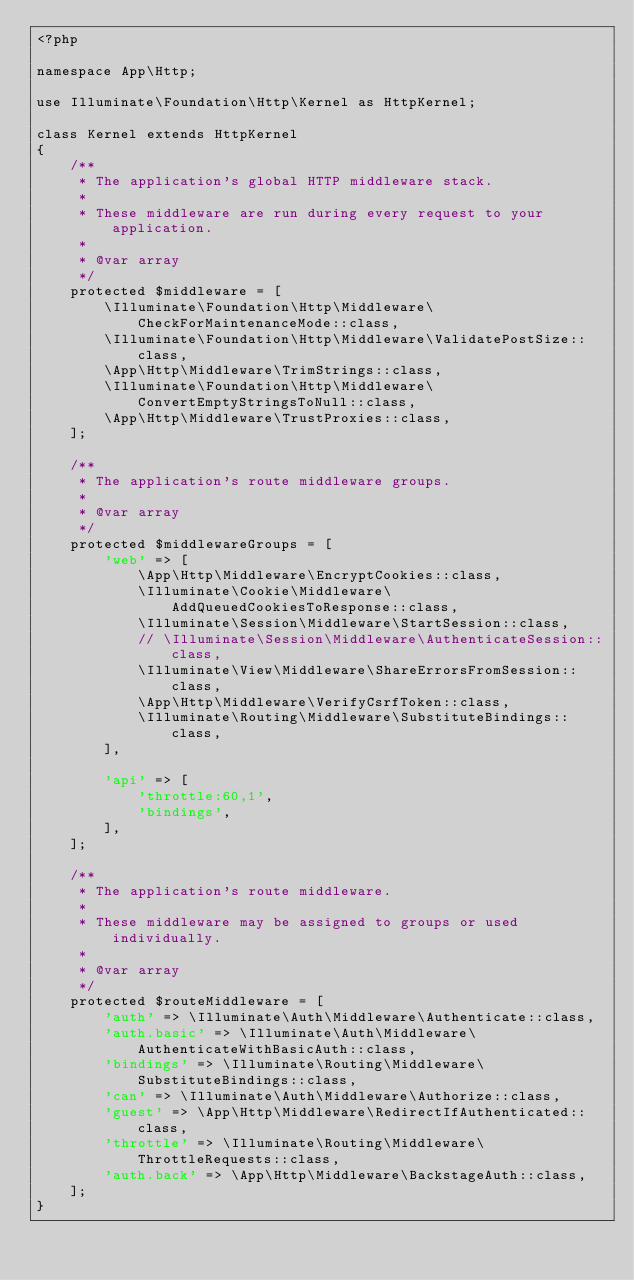<code> <loc_0><loc_0><loc_500><loc_500><_PHP_><?php

namespace App\Http;

use Illuminate\Foundation\Http\Kernel as HttpKernel;

class Kernel extends HttpKernel
{
    /**
     * The application's global HTTP middleware stack.
     *
     * These middleware are run during every request to your application.
     *
     * @var array
     */
    protected $middleware = [
        \Illuminate\Foundation\Http\Middleware\CheckForMaintenanceMode::class,
        \Illuminate\Foundation\Http\Middleware\ValidatePostSize::class,
        \App\Http\Middleware\TrimStrings::class,
        \Illuminate\Foundation\Http\Middleware\ConvertEmptyStringsToNull::class,
        \App\Http\Middleware\TrustProxies::class,
    ];

    /**
     * The application's route middleware groups.
     *
     * @var array
     */
    protected $middlewareGroups = [
        'web' => [
            \App\Http\Middleware\EncryptCookies::class,
            \Illuminate\Cookie\Middleware\AddQueuedCookiesToResponse::class,
            \Illuminate\Session\Middleware\StartSession::class,
            // \Illuminate\Session\Middleware\AuthenticateSession::class,
            \Illuminate\View\Middleware\ShareErrorsFromSession::class,
            \App\Http\Middleware\VerifyCsrfToken::class,
            \Illuminate\Routing\Middleware\SubstituteBindings::class,
        ],

        'api' => [
            'throttle:60,1',
            'bindings',
        ],
    ];

    /**
     * The application's route middleware.
     *
     * These middleware may be assigned to groups or used individually.
     *
     * @var array
     */
    protected $routeMiddleware = [
        'auth' => \Illuminate\Auth\Middleware\Authenticate::class,
        'auth.basic' => \Illuminate\Auth\Middleware\AuthenticateWithBasicAuth::class,
        'bindings' => \Illuminate\Routing\Middleware\SubstituteBindings::class,
        'can' => \Illuminate\Auth\Middleware\Authorize::class,
        'guest' => \App\Http\Middleware\RedirectIfAuthenticated::class,
        'throttle' => \Illuminate\Routing\Middleware\ThrottleRequests::class,
        'auth.back' => \App\Http\Middleware\BackstageAuth::class,
    ];
}
</code> 